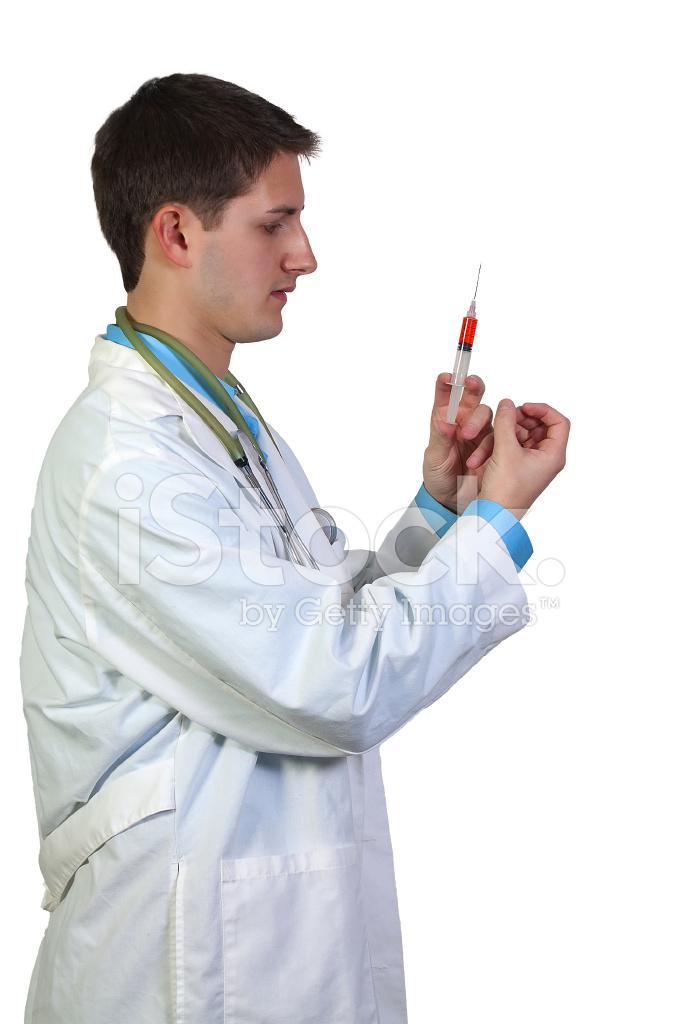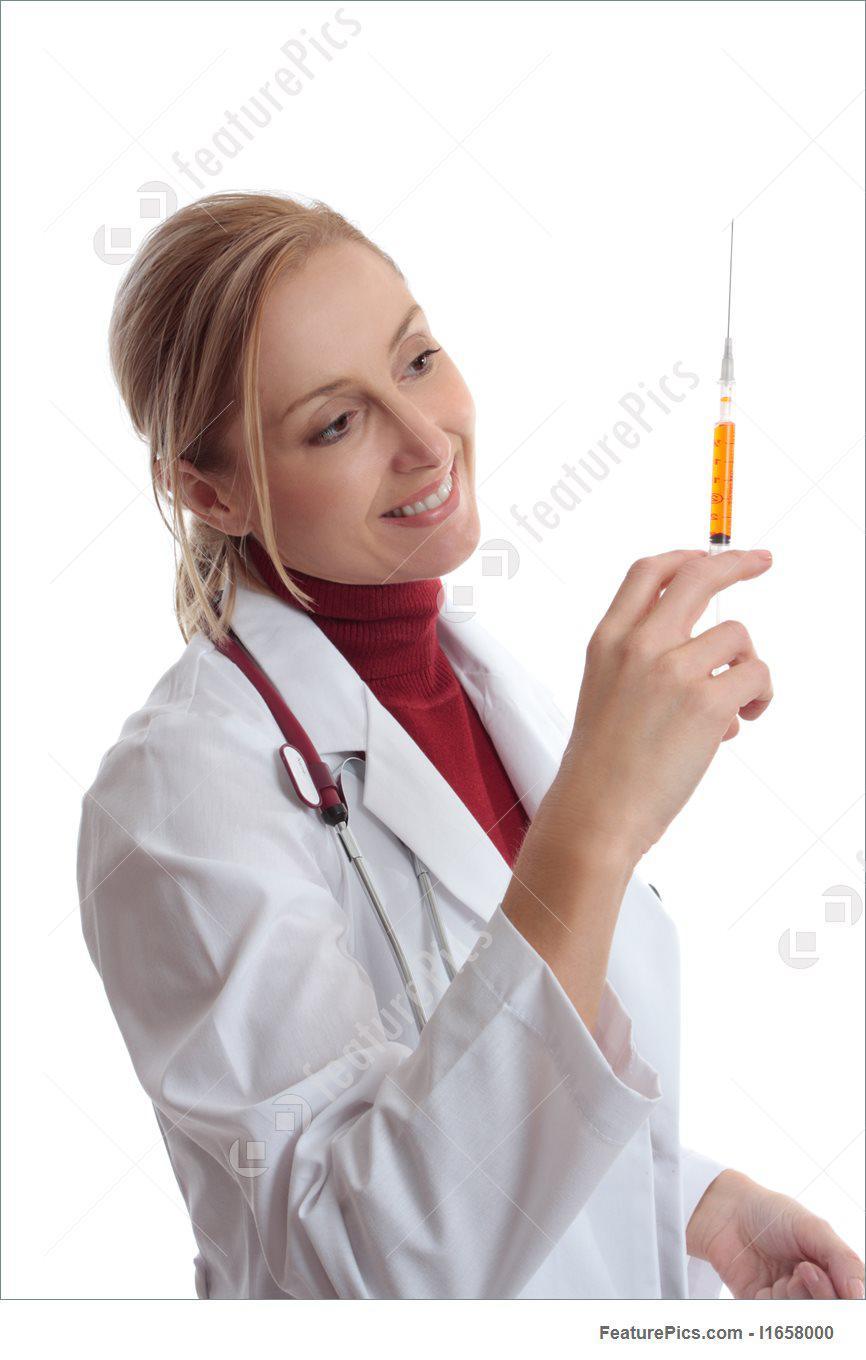The first image is the image on the left, the second image is the image on the right. Examine the images to the left and right. Is the description "Two women are holding syringes." accurate? Answer yes or no. No. The first image is the image on the left, the second image is the image on the right. Considering the images on both sides, is "There are two women holding needles." valid? Answer yes or no. No. 